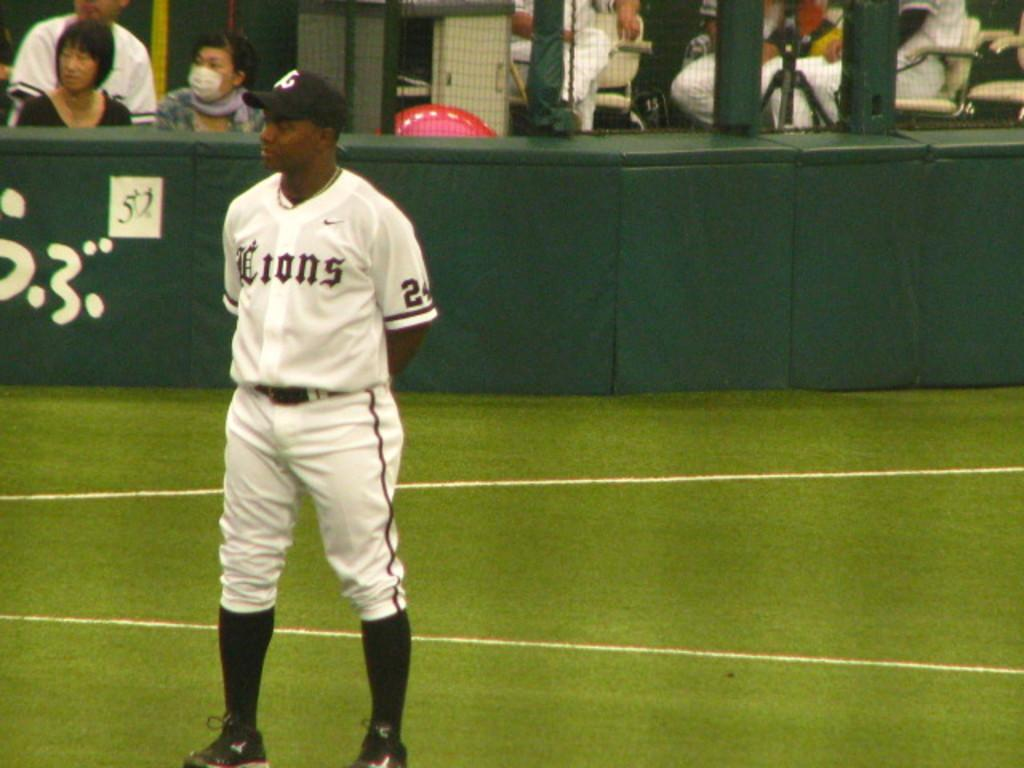Provide a one-sentence caption for the provided image. A player for the Lions stands on the field. 